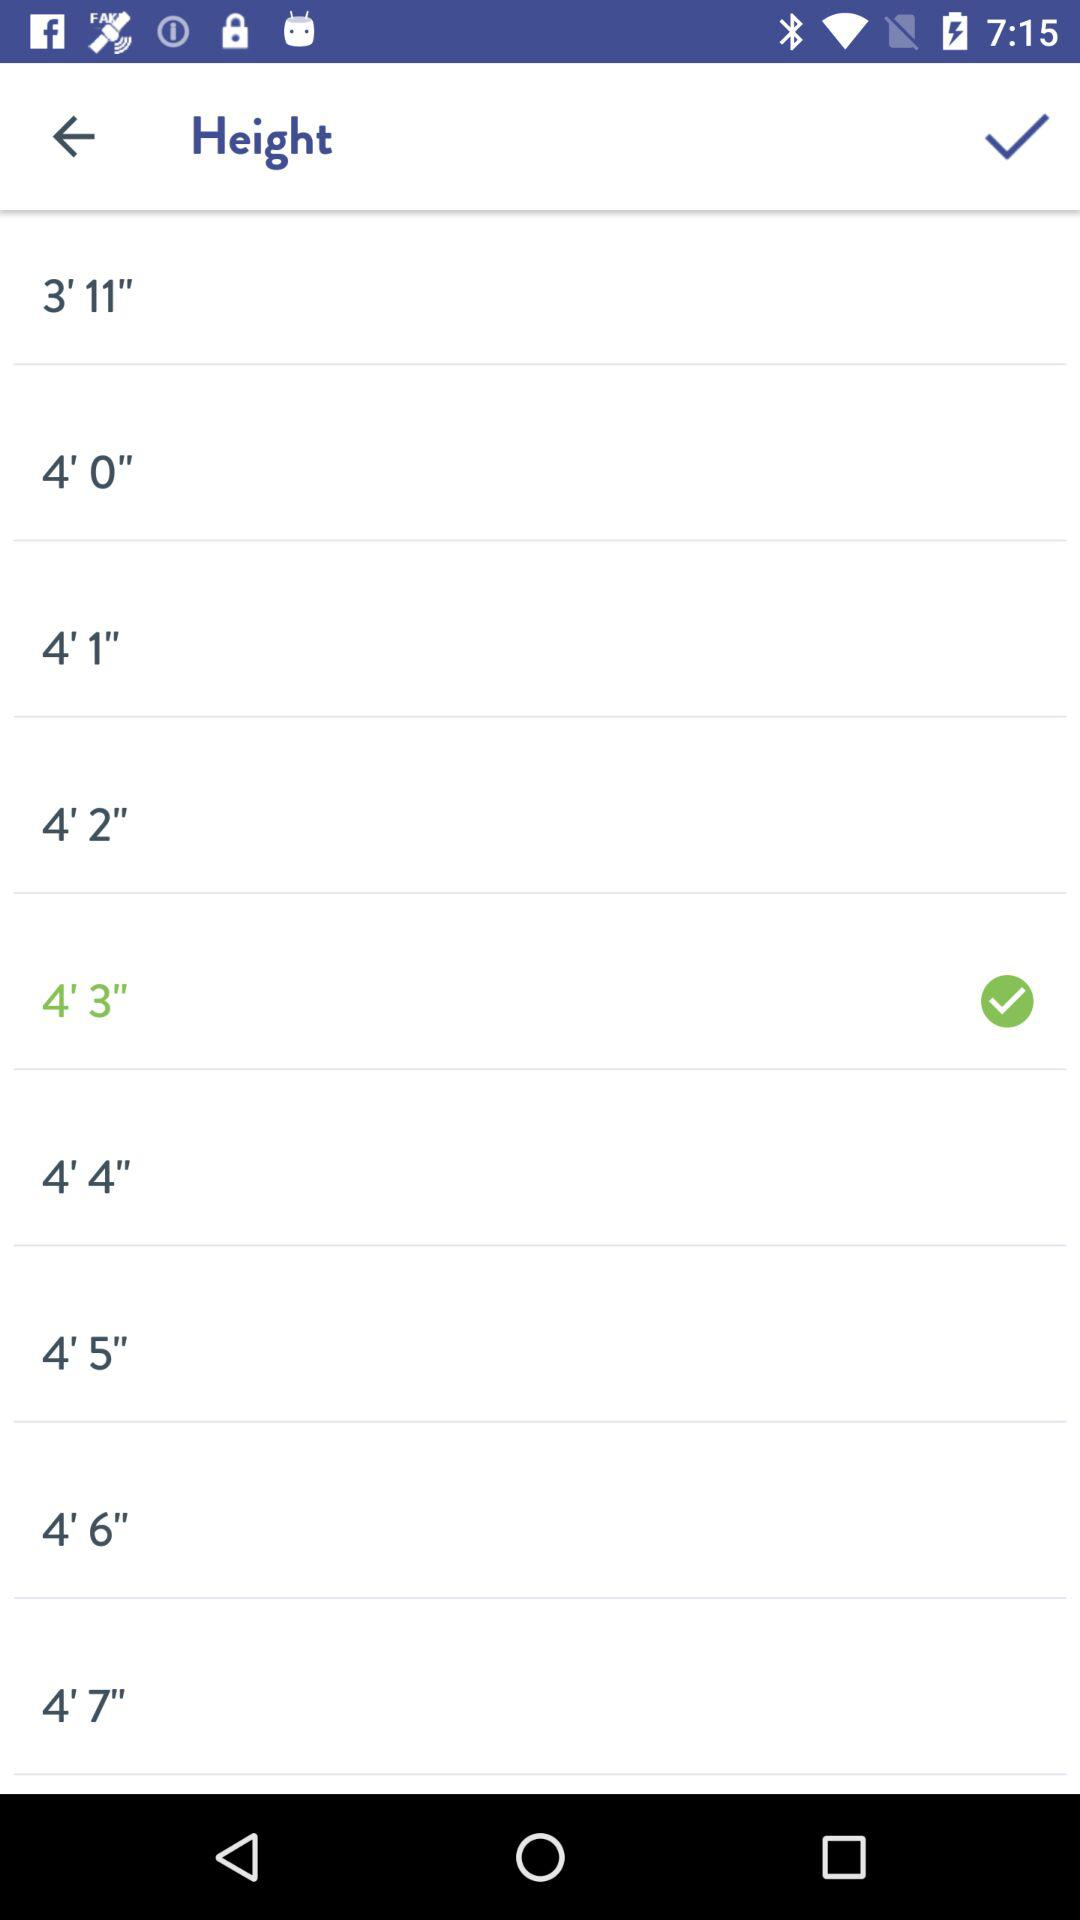What is the selected height? The selected height is 4'3". 